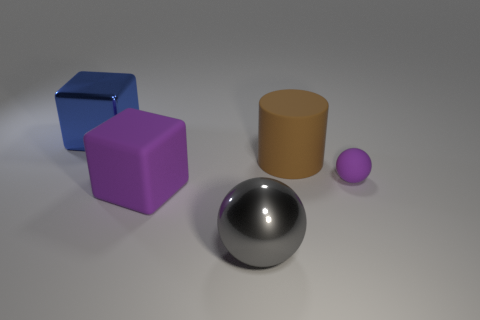Add 1 large blue metallic things. How many objects exist? 6 Subtract all cylinders. How many objects are left? 4 Add 3 cyan matte things. How many cyan matte things exist? 3 Subtract 0 purple cylinders. How many objects are left? 5 Subtract all small yellow metal cubes. Subtract all purple objects. How many objects are left? 3 Add 4 large blue metal objects. How many large blue metal objects are left? 5 